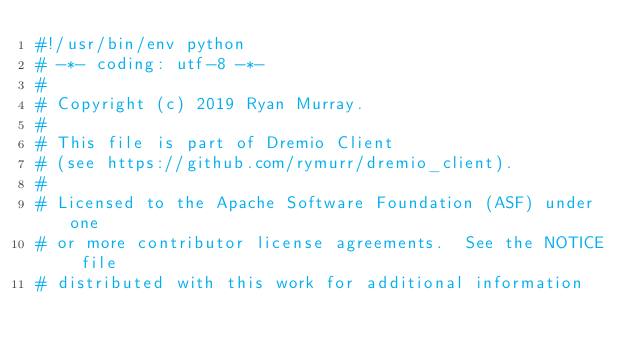<code> <loc_0><loc_0><loc_500><loc_500><_Python_>#!/usr/bin/env python
# -*- coding: utf-8 -*-
#
# Copyright (c) 2019 Ryan Murray.
#
# This file is part of Dremio Client
# (see https://github.com/rymurr/dremio_client).
#
# Licensed to the Apache Software Foundation (ASF) under one
# or more contributor license agreements.  See the NOTICE file
# distributed with this work for additional information</code> 